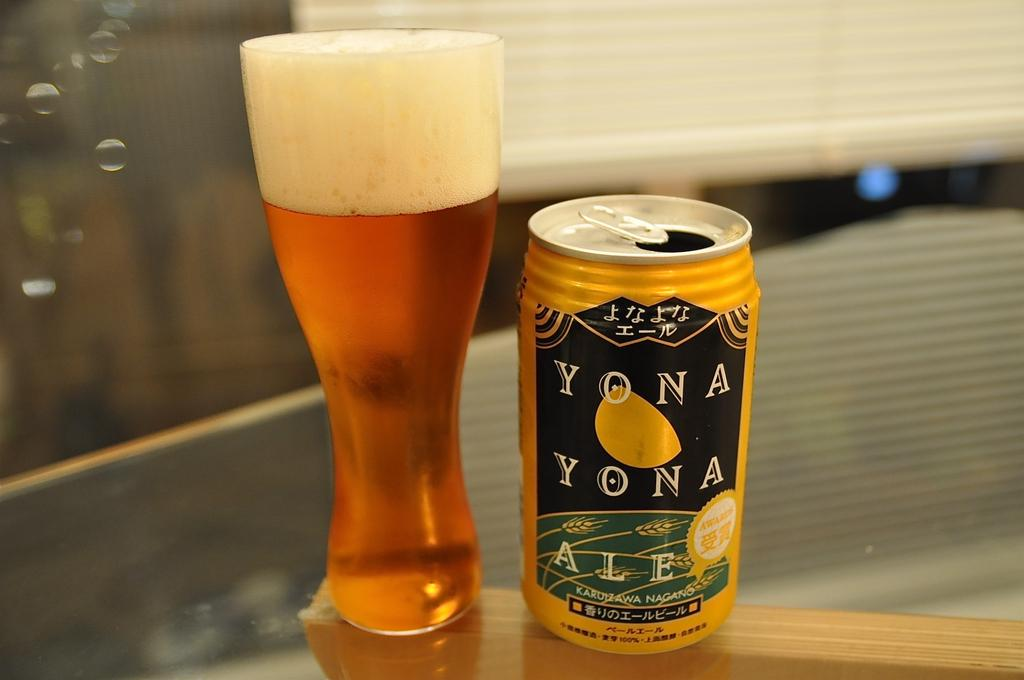Provide a one-sentence caption for the provided image. A can of Yona Yona ale standing next to a glass. 